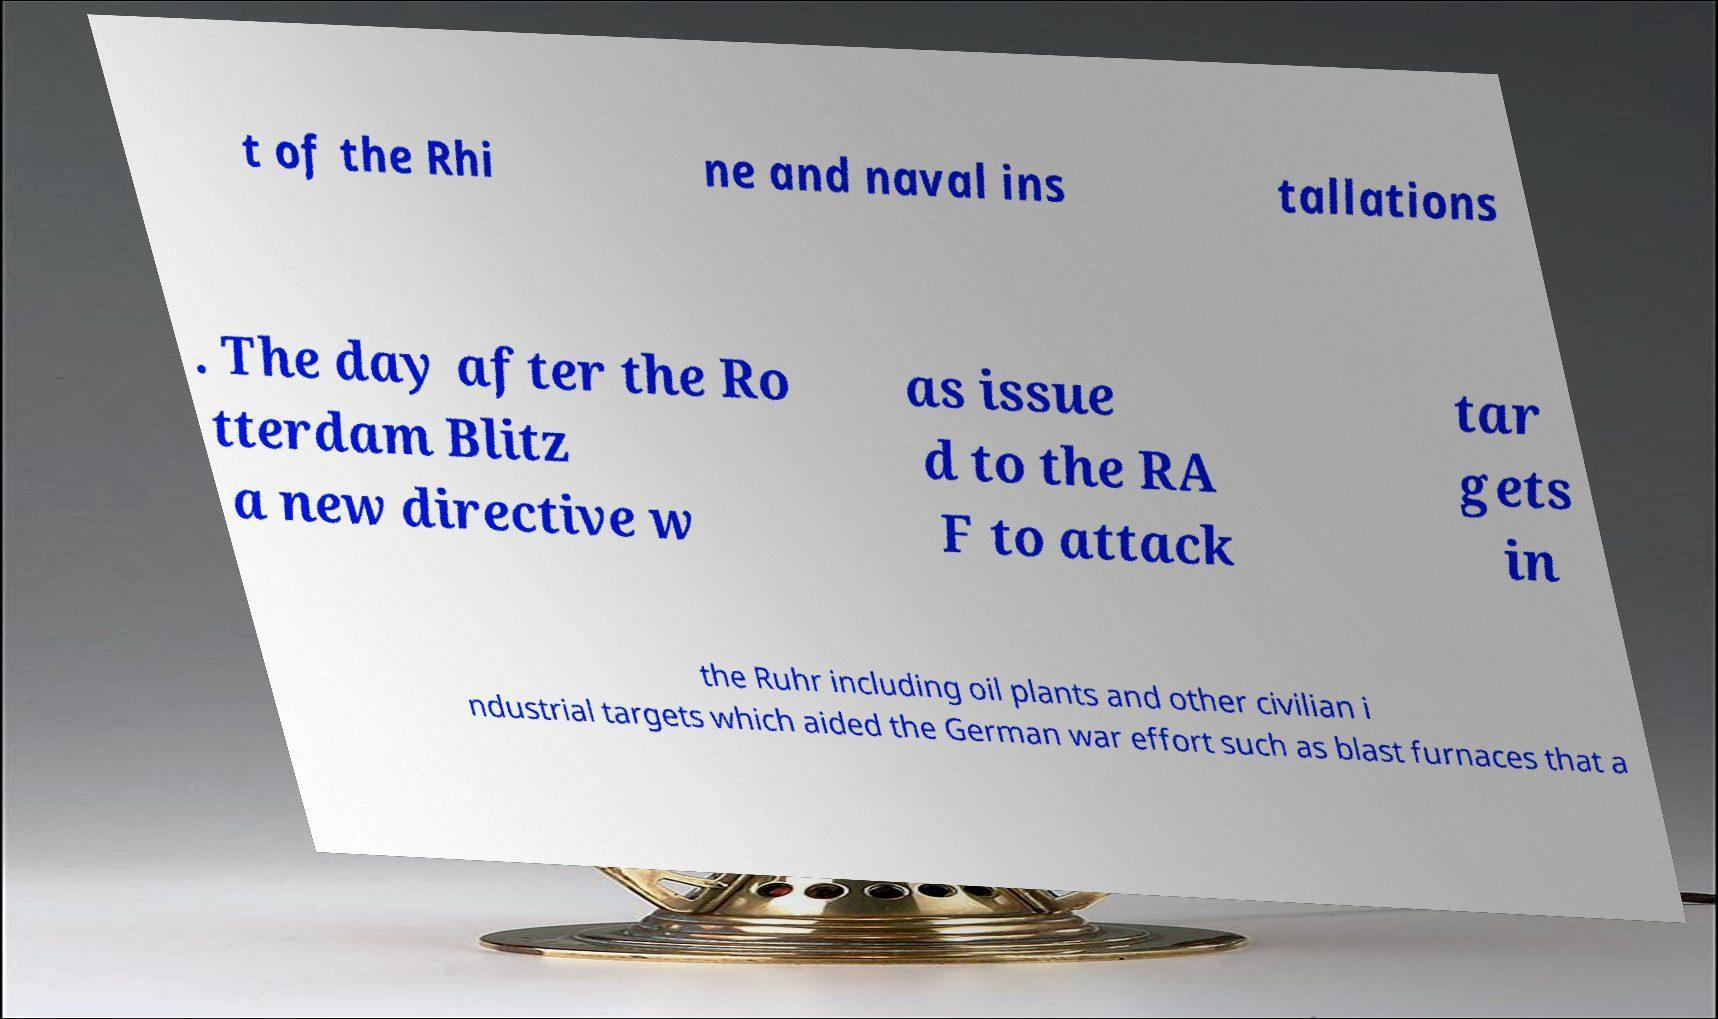Could you extract and type out the text from this image? t of the Rhi ne and naval ins tallations . The day after the Ro tterdam Blitz a new directive w as issue d to the RA F to attack tar gets in the Ruhr including oil plants and other civilian i ndustrial targets which aided the German war effort such as blast furnaces that a 